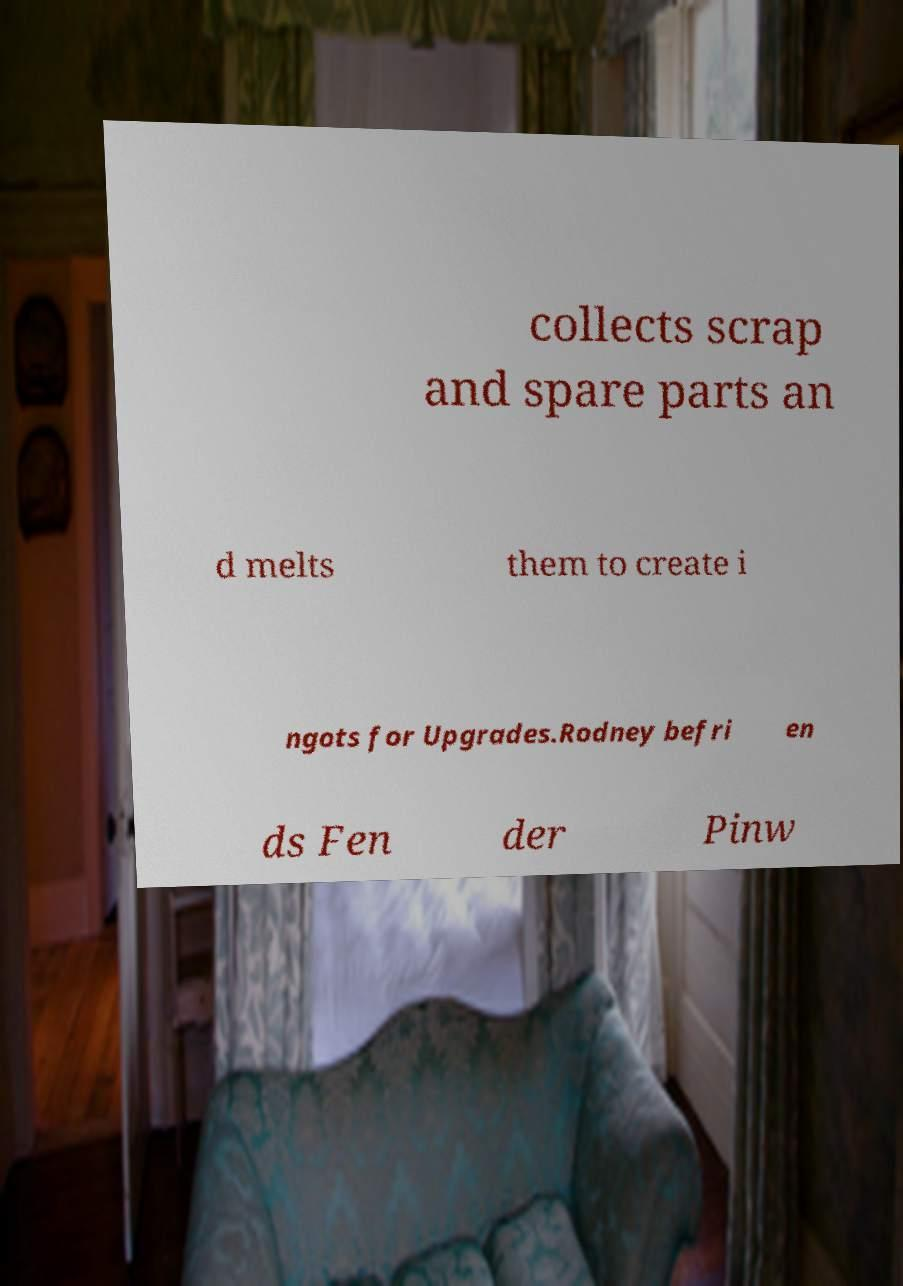There's text embedded in this image that I need extracted. Can you transcribe it verbatim? collects scrap and spare parts an d melts them to create i ngots for Upgrades.Rodney befri en ds Fen der Pinw 